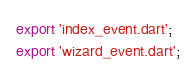<code> <loc_0><loc_0><loc_500><loc_500><_Dart_>export 'index_event.dart';
export 'wizard_event.dart';
</code> 